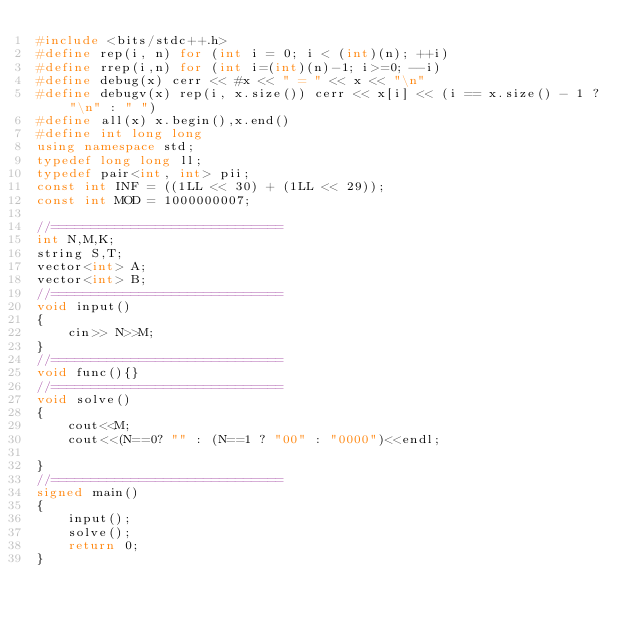Convert code to text. <code><loc_0><loc_0><loc_500><loc_500><_C++_>#include <bits/stdc++.h>
#define rep(i, n) for (int i = 0; i < (int)(n); ++i)
#define rrep(i,n) for (int i=(int)(n)-1; i>=0; --i)
#define debug(x) cerr << #x << " = " << x << "\n"
#define debugv(x) rep(i, x.size()) cerr << x[i] << (i == x.size() - 1 ? "\n" : " ")
#define all(x) x.begin(),x.end()
#define int long long
using namespace std;
typedef long long ll;
typedef pair<int, int> pii;
const int INF = ((1LL << 30) + (1LL << 29));
const int MOD = 1000000007;

//=============================
int N,M,K;
string S,T;
vector<int> A;
vector<int> B;
//=============================
void input()
{
    cin>> N>>M;
}
//=============================
void func(){}
//=============================
void solve()
{
    cout<<M;
    cout<<(N==0? "" : (N==1 ? "00" : "0000")<<endl;
    
}
//=============================
signed main()
{
    input();
    solve();
    return 0;
}</code> 